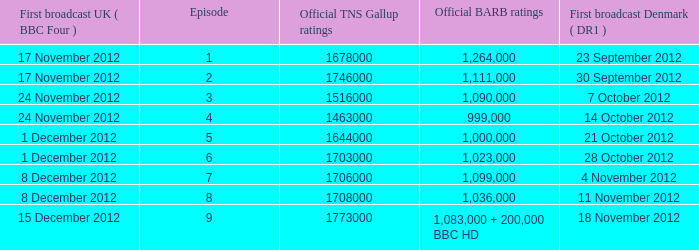When was the episode with a 1,036,000 BARB rating first aired in Denmark? 11 November 2012. 